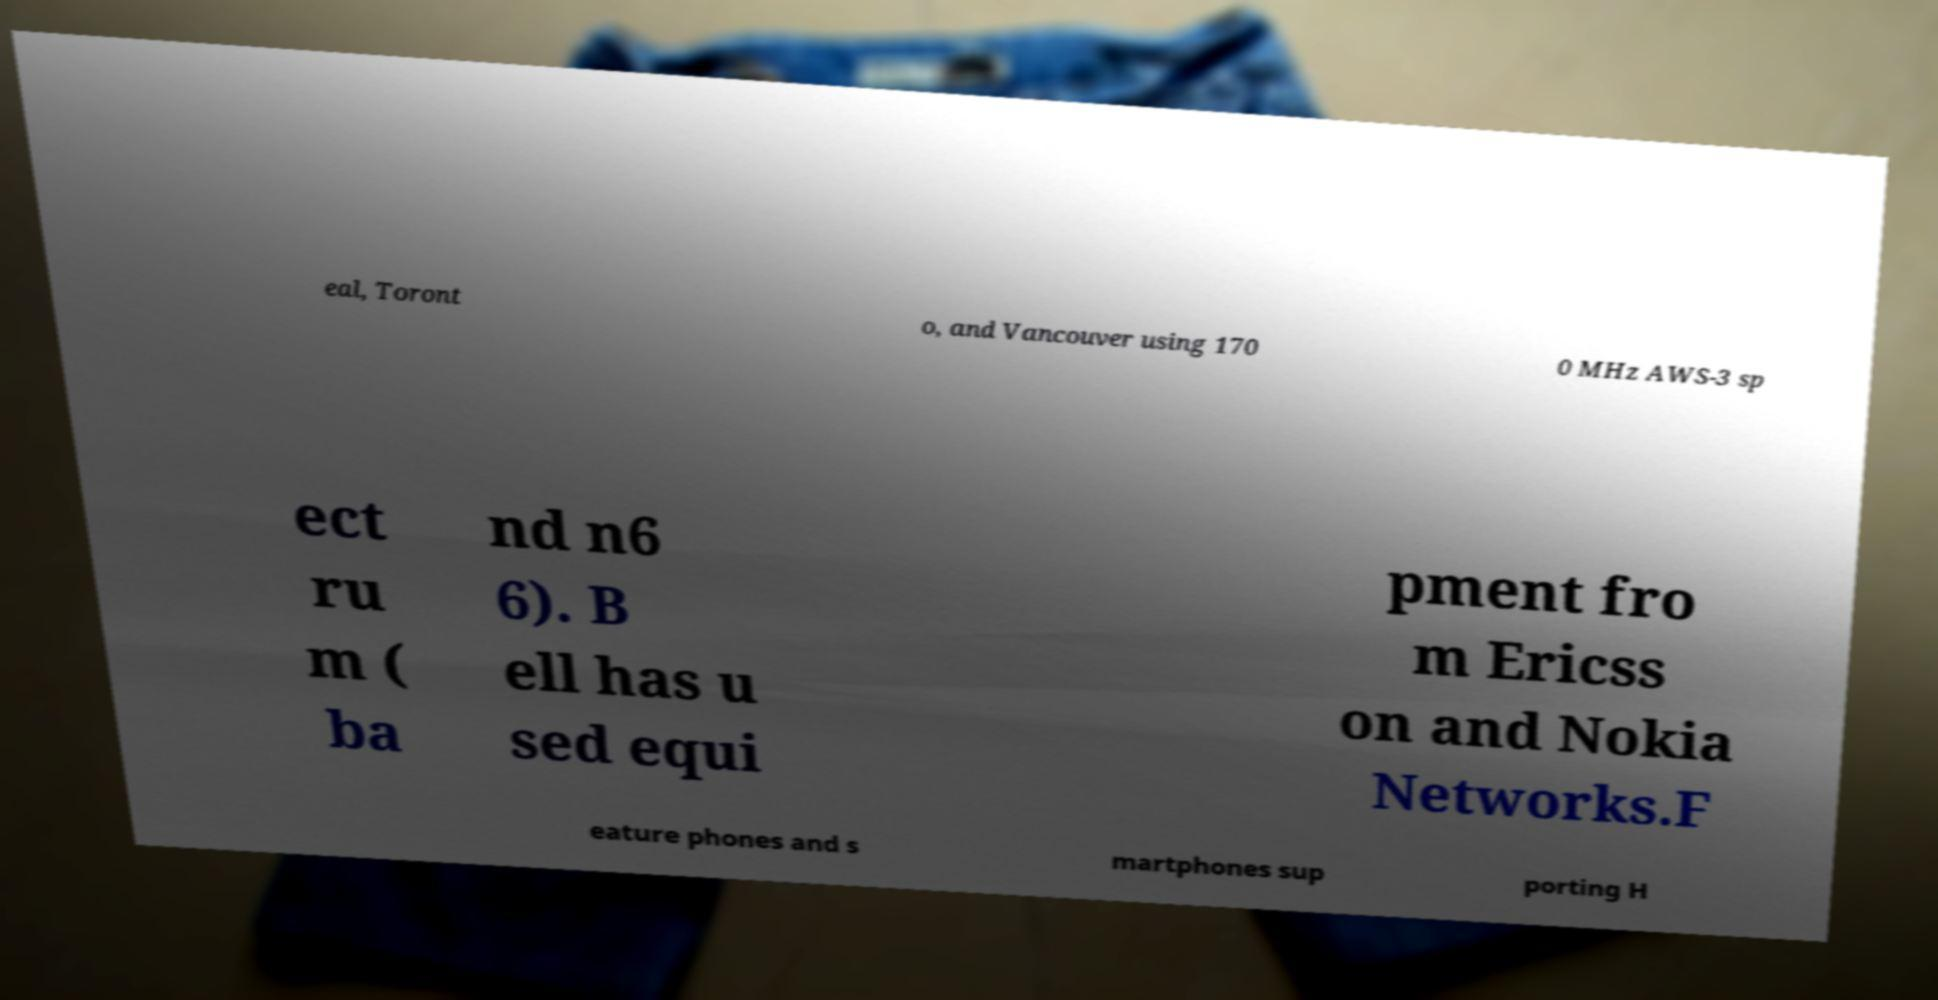There's text embedded in this image that I need extracted. Can you transcribe it verbatim? eal, Toront o, and Vancouver using 170 0 MHz AWS-3 sp ect ru m ( ba nd n6 6). B ell has u sed equi pment fro m Ericss on and Nokia Networks.F eature phones and s martphones sup porting H 